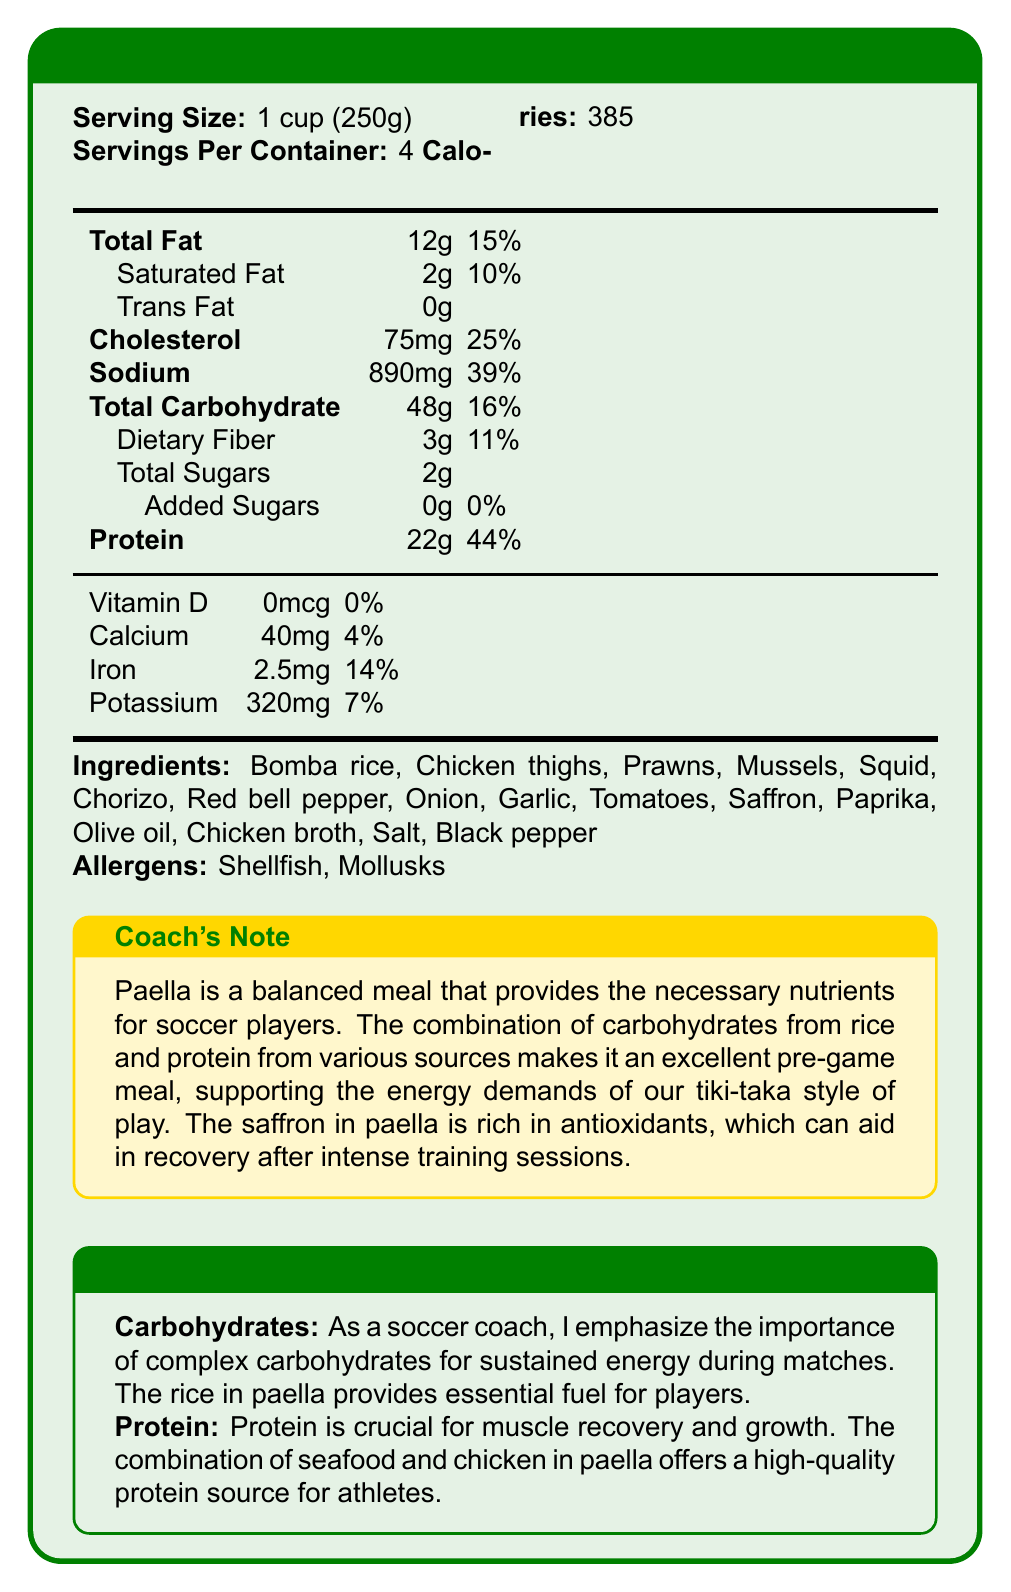what is the serving size? The serving size is clearly stated at the top of the document: "Serving Size: 1 cup (250g)".
Answer: 1 cup (250g) how many servings are in the container? The document mentions that there are 4 servings per container.
Answer: 4 how many grams of total carbohydrates are there per serving? In the nutrition facts table, it states "Total Carbohydrate: 48g".
Answer: 48g how many grams of protein are in one serving? The document lists "Protein: 22g" in the nutrition facts.
Answer: 22g what are two major allergen alerts mentioned in the document? The allergen section lists "Shellfish" and "Mollusks".
Answer: Shellfish, Mollusks which nutrient contributes the highest daily value percentage per serving? A. Total Fat B. Cholesterol C. Protein D. Sodium Protein contributes 44% of the daily value, which is higher than the contributions from Total Fat, Cholesterol, and Sodium.
Answer: C. Protein how much sodium is in one serving of paella? A. 750mg B. 890mg C. 300mg D. 1000mg The nutrition facts table shows "Sodium: 890mg".
Answer: B. 890mg does the paella contain any added sugars? The document specifies "Added Sugars: 0g".
Answer: No is this paella a good source of calcium? The document indicates that there is only 4% of the daily value of calcium per serving.
Answer: No what is the main idea of the coach's note? The coach's note highlights that the combination of carbohydrates and protein in paella makes it an excellent pre-game meal, supporting the energy demands of soccer and aiding in recovery.
Answer: Paella is a balanced meal that supports soccer players by providing necessary nutrients for energy and recovery. what brand of olive oil is used in the paella? The document does not specify the brand of olive oil used in the ingredient list.
Answer: Cannot be determined 